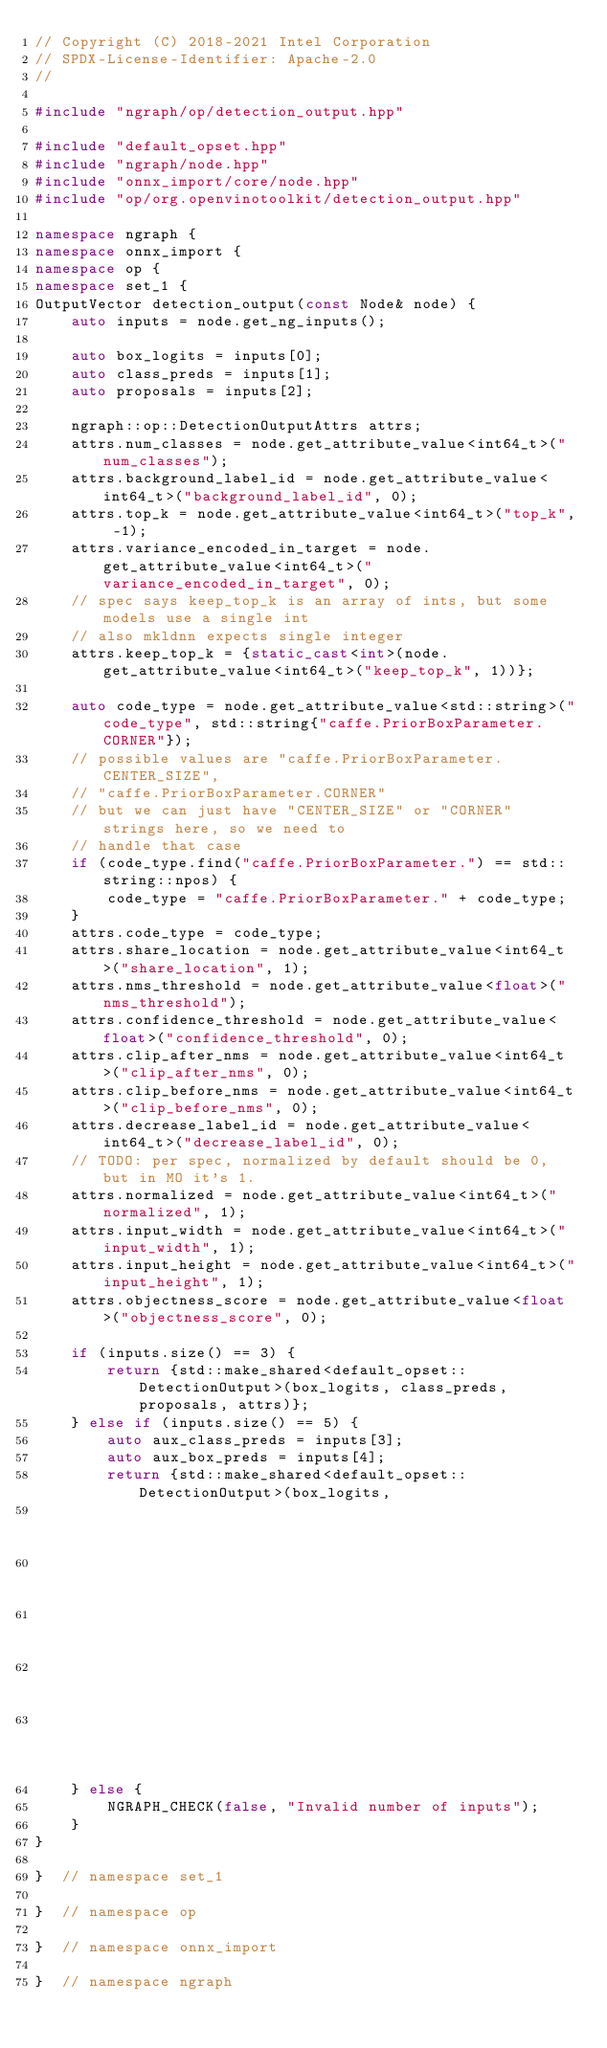Convert code to text. <code><loc_0><loc_0><loc_500><loc_500><_C++_>// Copyright (C) 2018-2021 Intel Corporation
// SPDX-License-Identifier: Apache-2.0
//

#include "ngraph/op/detection_output.hpp"

#include "default_opset.hpp"
#include "ngraph/node.hpp"
#include "onnx_import/core/node.hpp"
#include "op/org.openvinotoolkit/detection_output.hpp"

namespace ngraph {
namespace onnx_import {
namespace op {
namespace set_1 {
OutputVector detection_output(const Node& node) {
    auto inputs = node.get_ng_inputs();

    auto box_logits = inputs[0];
    auto class_preds = inputs[1];
    auto proposals = inputs[2];

    ngraph::op::DetectionOutputAttrs attrs;
    attrs.num_classes = node.get_attribute_value<int64_t>("num_classes");
    attrs.background_label_id = node.get_attribute_value<int64_t>("background_label_id", 0);
    attrs.top_k = node.get_attribute_value<int64_t>("top_k", -1);
    attrs.variance_encoded_in_target = node.get_attribute_value<int64_t>("variance_encoded_in_target", 0);
    // spec says keep_top_k is an array of ints, but some models use a single int
    // also mkldnn expects single integer
    attrs.keep_top_k = {static_cast<int>(node.get_attribute_value<int64_t>("keep_top_k", 1))};

    auto code_type = node.get_attribute_value<std::string>("code_type", std::string{"caffe.PriorBoxParameter.CORNER"});
    // possible values are "caffe.PriorBoxParameter.CENTER_SIZE",
    // "caffe.PriorBoxParameter.CORNER"
    // but we can just have "CENTER_SIZE" or "CORNER" strings here, so we need to
    // handle that case
    if (code_type.find("caffe.PriorBoxParameter.") == std::string::npos) {
        code_type = "caffe.PriorBoxParameter." + code_type;
    }
    attrs.code_type = code_type;
    attrs.share_location = node.get_attribute_value<int64_t>("share_location", 1);
    attrs.nms_threshold = node.get_attribute_value<float>("nms_threshold");
    attrs.confidence_threshold = node.get_attribute_value<float>("confidence_threshold", 0);
    attrs.clip_after_nms = node.get_attribute_value<int64_t>("clip_after_nms", 0);
    attrs.clip_before_nms = node.get_attribute_value<int64_t>("clip_before_nms", 0);
    attrs.decrease_label_id = node.get_attribute_value<int64_t>("decrease_label_id", 0);
    // TODO: per spec, normalized by default should be 0, but in MO it's 1.
    attrs.normalized = node.get_attribute_value<int64_t>("normalized", 1);
    attrs.input_width = node.get_attribute_value<int64_t>("input_width", 1);
    attrs.input_height = node.get_attribute_value<int64_t>("input_height", 1);
    attrs.objectness_score = node.get_attribute_value<float>("objectness_score", 0);

    if (inputs.size() == 3) {
        return {std::make_shared<default_opset::DetectionOutput>(box_logits, class_preds, proposals, attrs)};
    } else if (inputs.size() == 5) {
        auto aux_class_preds = inputs[3];
        auto aux_box_preds = inputs[4];
        return {std::make_shared<default_opset::DetectionOutput>(box_logits,
                                                                 class_preds,
                                                                 proposals,
                                                                 aux_class_preds,
                                                                 aux_box_preds,
                                                                 attrs)};
    } else {
        NGRAPH_CHECK(false, "Invalid number of inputs");
    }
}

}  // namespace set_1

}  // namespace op

}  // namespace onnx_import

}  // namespace ngraph
</code> 